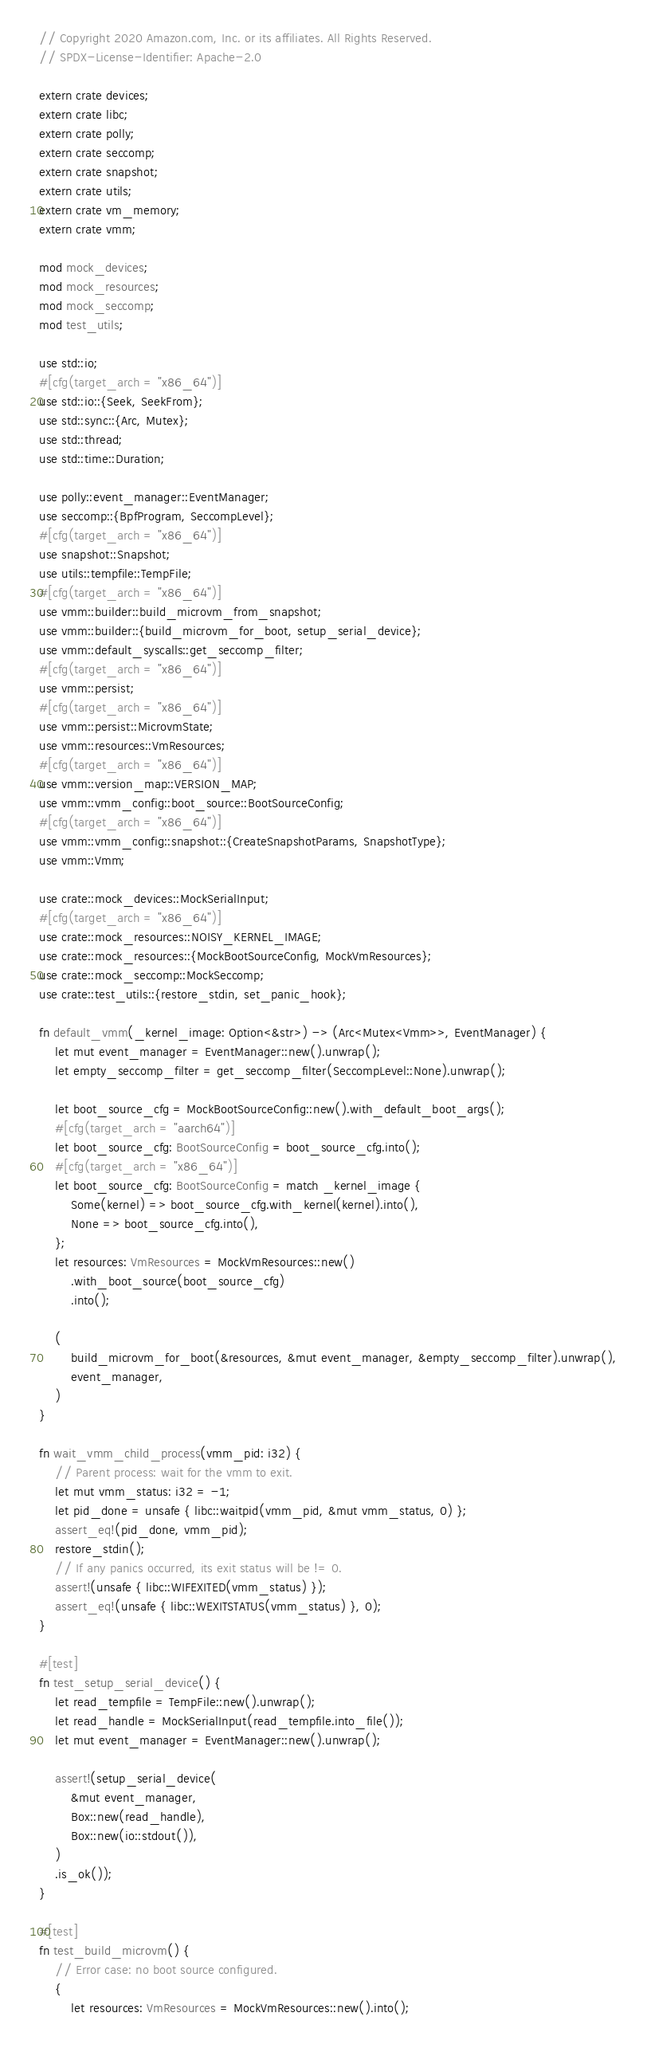Convert code to text. <code><loc_0><loc_0><loc_500><loc_500><_Rust_>// Copyright 2020 Amazon.com, Inc. or its affiliates. All Rights Reserved.
// SPDX-License-Identifier: Apache-2.0

extern crate devices;
extern crate libc;
extern crate polly;
extern crate seccomp;
extern crate snapshot;
extern crate utils;
extern crate vm_memory;
extern crate vmm;

mod mock_devices;
mod mock_resources;
mod mock_seccomp;
mod test_utils;

use std::io;
#[cfg(target_arch = "x86_64")]
use std::io::{Seek, SeekFrom};
use std::sync::{Arc, Mutex};
use std::thread;
use std::time::Duration;

use polly::event_manager::EventManager;
use seccomp::{BpfProgram, SeccompLevel};
#[cfg(target_arch = "x86_64")]
use snapshot::Snapshot;
use utils::tempfile::TempFile;
#[cfg(target_arch = "x86_64")]
use vmm::builder::build_microvm_from_snapshot;
use vmm::builder::{build_microvm_for_boot, setup_serial_device};
use vmm::default_syscalls::get_seccomp_filter;
#[cfg(target_arch = "x86_64")]
use vmm::persist;
#[cfg(target_arch = "x86_64")]
use vmm::persist::MicrovmState;
use vmm::resources::VmResources;
#[cfg(target_arch = "x86_64")]
use vmm::version_map::VERSION_MAP;
use vmm::vmm_config::boot_source::BootSourceConfig;
#[cfg(target_arch = "x86_64")]
use vmm::vmm_config::snapshot::{CreateSnapshotParams, SnapshotType};
use vmm::Vmm;

use crate::mock_devices::MockSerialInput;
#[cfg(target_arch = "x86_64")]
use crate::mock_resources::NOISY_KERNEL_IMAGE;
use crate::mock_resources::{MockBootSourceConfig, MockVmResources};
use crate::mock_seccomp::MockSeccomp;
use crate::test_utils::{restore_stdin, set_panic_hook};

fn default_vmm(_kernel_image: Option<&str>) -> (Arc<Mutex<Vmm>>, EventManager) {
    let mut event_manager = EventManager::new().unwrap();
    let empty_seccomp_filter = get_seccomp_filter(SeccompLevel::None).unwrap();

    let boot_source_cfg = MockBootSourceConfig::new().with_default_boot_args();
    #[cfg(target_arch = "aarch64")]
    let boot_source_cfg: BootSourceConfig = boot_source_cfg.into();
    #[cfg(target_arch = "x86_64")]
    let boot_source_cfg: BootSourceConfig = match _kernel_image {
        Some(kernel) => boot_source_cfg.with_kernel(kernel).into(),
        None => boot_source_cfg.into(),
    };
    let resources: VmResources = MockVmResources::new()
        .with_boot_source(boot_source_cfg)
        .into();

    (
        build_microvm_for_boot(&resources, &mut event_manager, &empty_seccomp_filter).unwrap(),
        event_manager,
    )
}

fn wait_vmm_child_process(vmm_pid: i32) {
    // Parent process: wait for the vmm to exit.
    let mut vmm_status: i32 = -1;
    let pid_done = unsafe { libc::waitpid(vmm_pid, &mut vmm_status, 0) };
    assert_eq!(pid_done, vmm_pid);
    restore_stdin();
    // If any panics occurred, its exit status will be != 0.
    assert!(unsafe { libc::WIFEXITED(vmm_status) });
    assert_eq!(unsafe { libc::WEXITSTATUS(vmm_status) }, 0);
}

#[test]
fn test_setup_serial_device() {
    let read_tempfile = TempFile::new().unwrap();
    let read_handle = MockSerialInput(read_tempfile.into_file());
    let mut event_manager = EventManager::new().unwrap();

    assert!(setup_serial_device(
        &mut event_manager,
        Box::new(read_handle),
        Box::new(io::stdout()),
    )
    .is_ok());
}

#[test]
fn test_build_microvm() {
    // Error case: no boot source configured.
    {
        let resources: VmResources = MockVmResources::new().into();</code> 